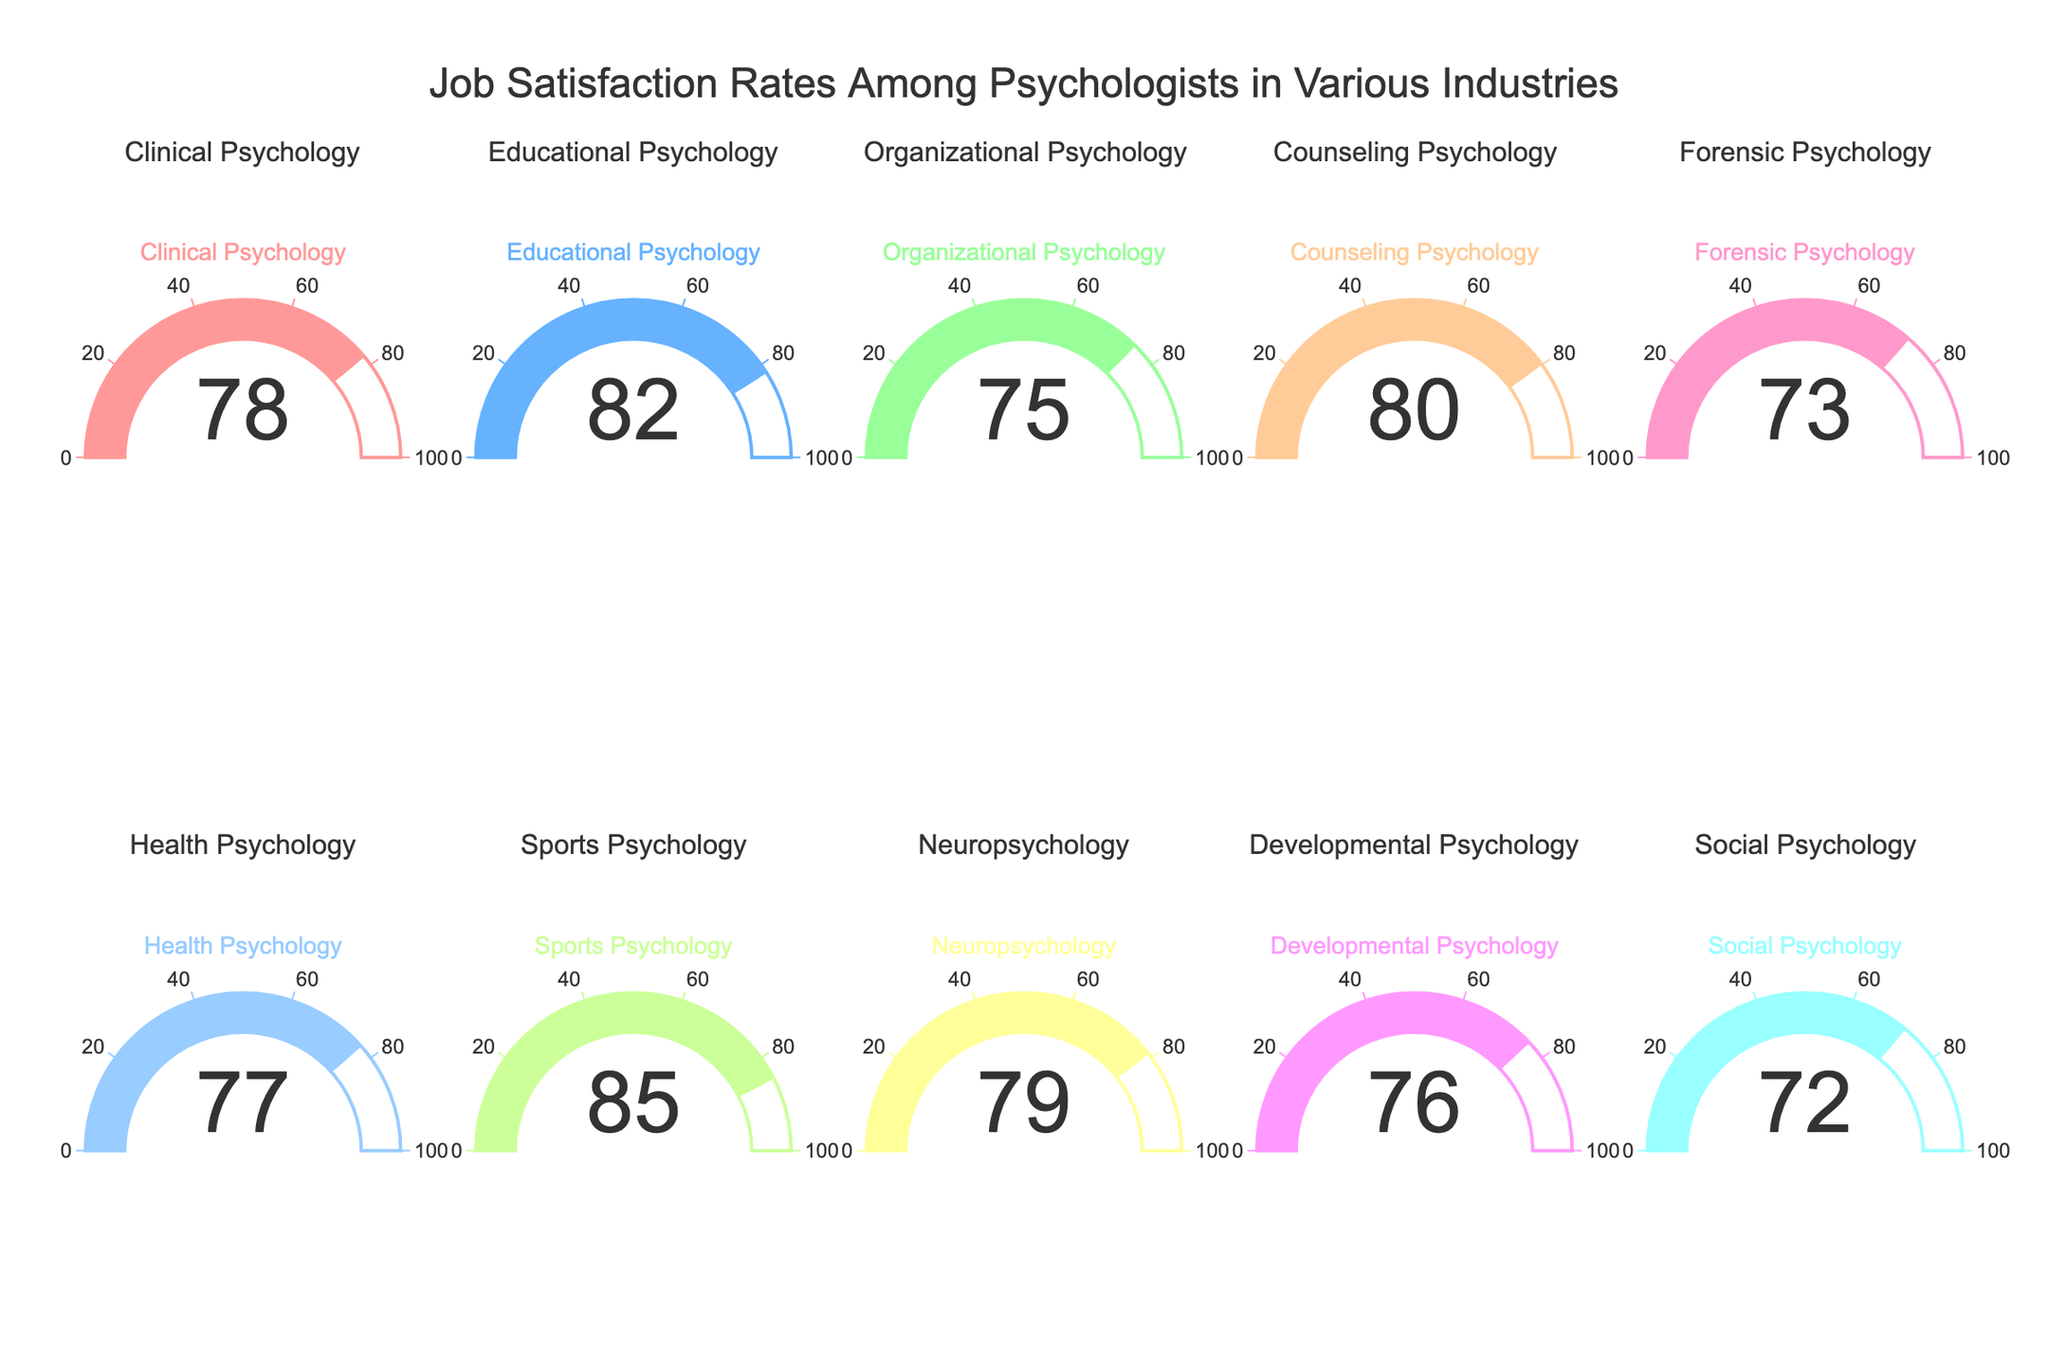What is the job satisfaction rate for Clinical Psychology? The gauge chart for Clinical Psychology shows a satisfaction rate of 78.
Answer: 78 Which psychology field has the highest job satisfaction rate? By examining all the gauges, Sports Psychology has the highest satisfaction rate at 85.
Answer: Sports Psychology What is the average job satisfaction rate for all the psychology fields? Sum all the satisfaction rates: 78 + 82 + 75 + 80 + 73 + 77 + 85 + 79 + 76 + 72 = 777. There are 10 fields, so the average is 777/10 = 77.7.
Answer: 77.7 Which fields have a job satisfaction rate higher than 80? Educational Psychology (82), Counseling Psychology (80), and Sports Psychology (85) have satisfaction rates higher than 80.
Answer: Educational Psychology, Counseling Psychology, Sports Psychology What's the difference in job satisfaction rates between Organizational Psychology and Forensic Psychology? The satisfaction rate for Organizational Psychology is 75, and for Forensic Psychology is 73. The difference is 75 - 73 = 2.
Answer: 2 What is the median job satisfaction rate among the psychology fields? Order the rates: 72, 73, 75, 76, 77, 78, 79, 80, 82, 85. The median is the average of the 5th and 6th values: (77 + 78)/2 = 77.5.
Answer: 77.5 How many psychology fields have job satisfaction rates below 75? Review the gauges with satisfaction rates below 75: Forensic Psychology (73) and Social Psychology (72).
Answer: 2 What is the range of job satisfaction rates across all fields? The highest rate is 85 (Sports Psychology), and the lowest is 72 (Social Psychology). The range is 85 - 72 = 13.
Answer: 13 Which two fields have the closest job satisfaction rates? Clinical Psychology (78) and Neuropsychology (79) have the closest rates, differing by just 1.
Answer: Clinical Psychology and Neuropsychology If you wanted to identify the overall trend in job satisfaction rates, what kind of trend would you note? The majority of the fields have rates between 70 and 80, suggesting that job satisfaction is generally high but varies slightly among the different fields. Specific outliers such as Sports Psychology (85) push the upper limit.
Answer: Generally high with slight variations 